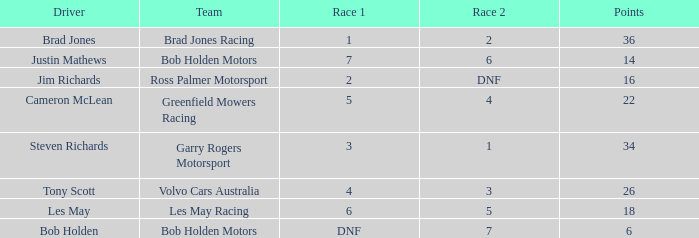Which pilot for bob holden motors has below 36 points and finished 7th in race 1? Justin Mathews. 